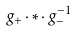<formula> <loc_0><loc_0><loc_500><loc_500>g _ { + } \cdot * \cdot g _ { - } ^ { - 1 }</formula> 